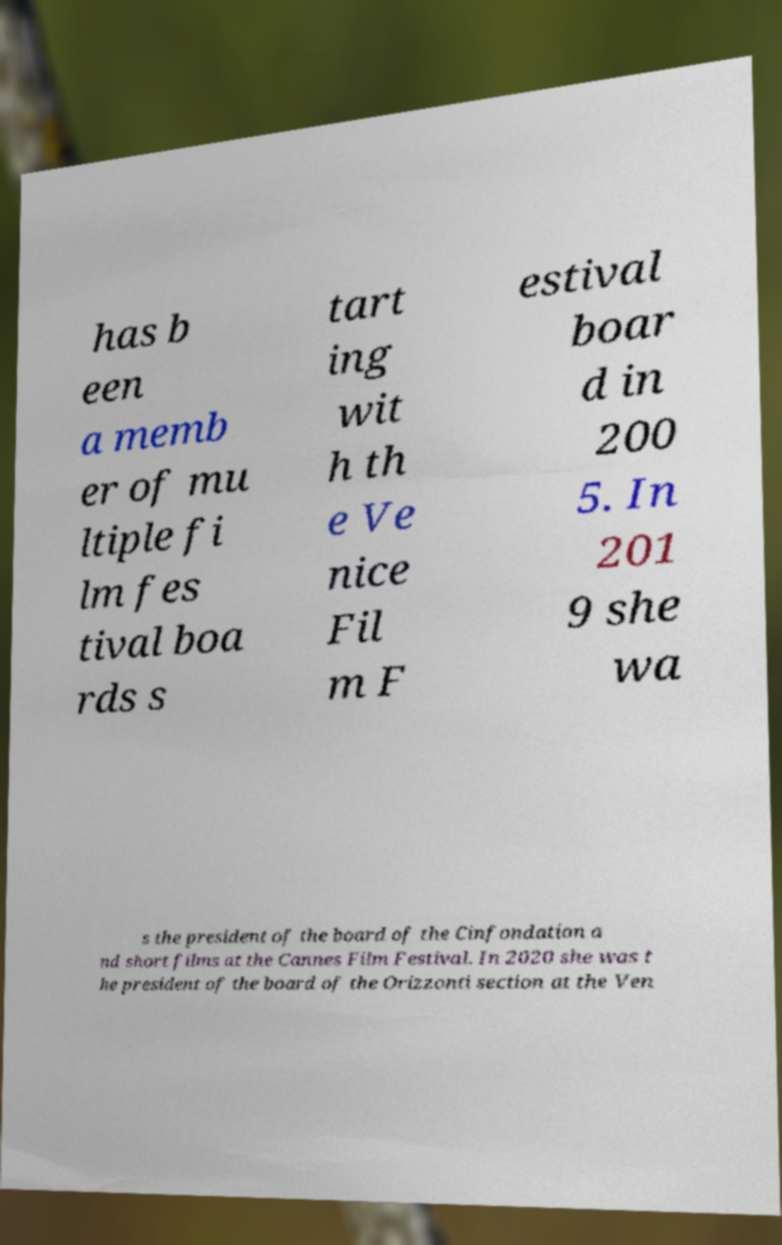Could you extract and type out the text from this image? has b een a memb er of mu ltiple fi lm fes tival boa rds s tart ing wit h th e Ve nice Fil m F estival boar d in 200 5. In 201 9 she wa s the president of the board of the Cinfondation a nd short films at the Cannes Film Festival. In 2020 she was t he president of the board of the Orizzonti section at the Ven 